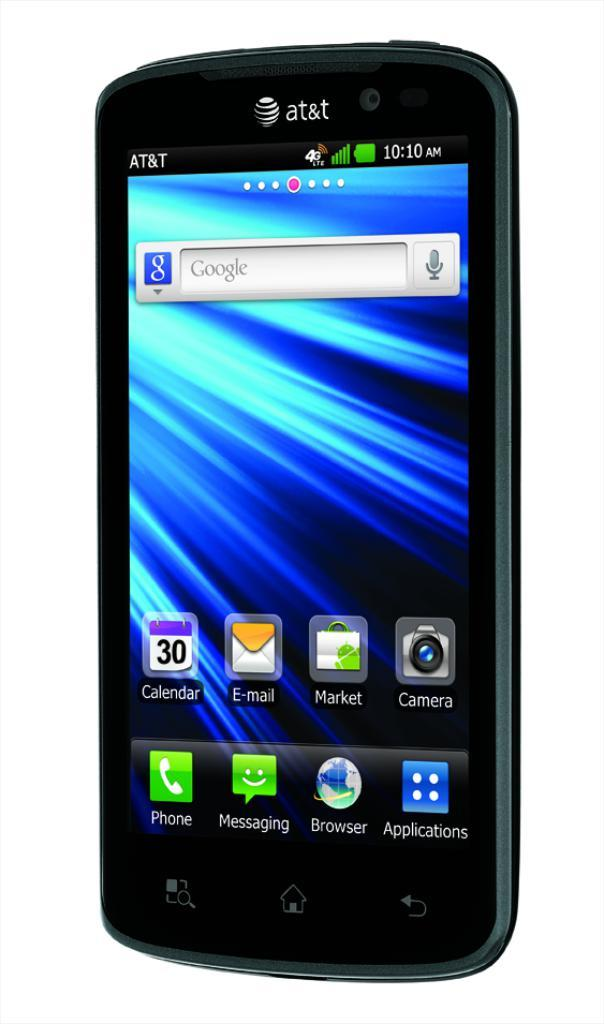<image>
Offer a succinct explanation of the picture presented. An AT&T smartphone with the calendar icon on it. 